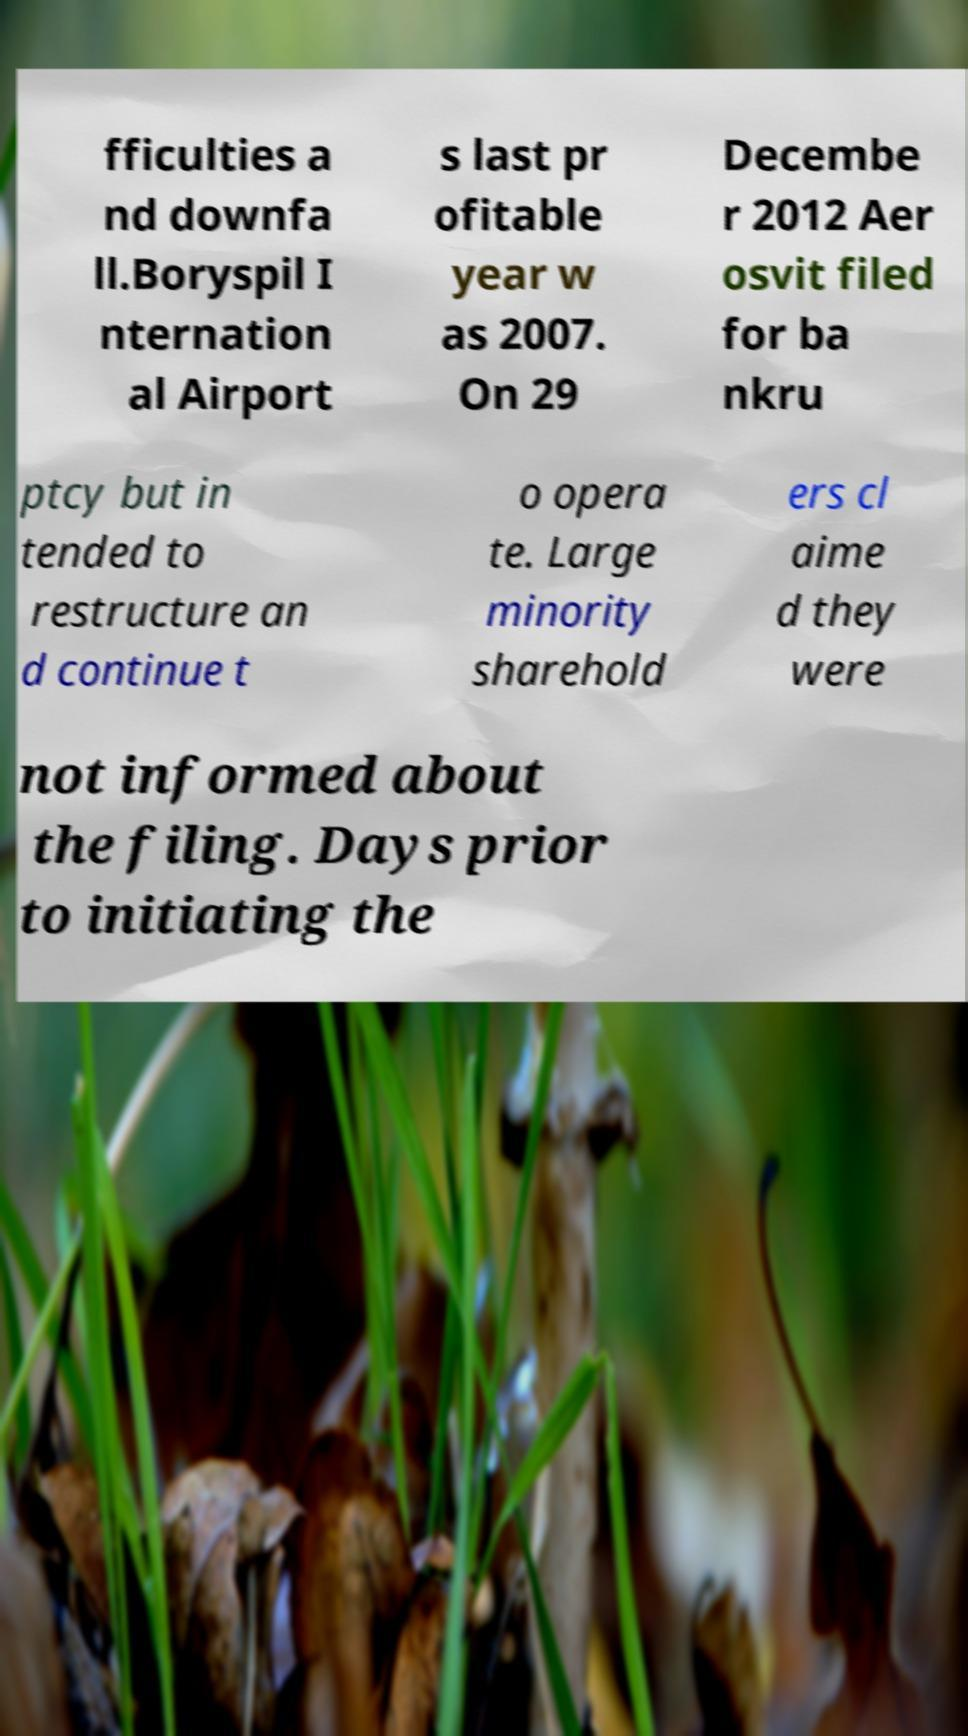Can you read and provide the text displayed in the image?This photo seems to have some interesting text. Can you extract and type it out for me? fficulties a nd downfa ll.Boryspil I nternation al Airport s last pr ofitable year w as 2007. On 29 Decembe r 2012 Aer osvit filed for ba nkru ptcy but in tended to restructure an d continue t o opera te. Large minority sharehold ers cl aime d they were not informed about the filing. Days prior to initiating the 